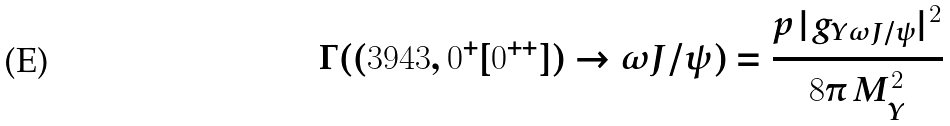<formula> <loc_0><loc_0><loc_500><loc_500>\Gamma ( ( 3 9 4 3 , 0 ^ { + } [ 0 ^ { + + } ] ) \to \omega J / \psi ) = \frac { p \, | g _ { Y \omega J / \psi } | ^ { 2 } } { 8 \pi \, M _ { Y } ^ { 2 } }</formula> 